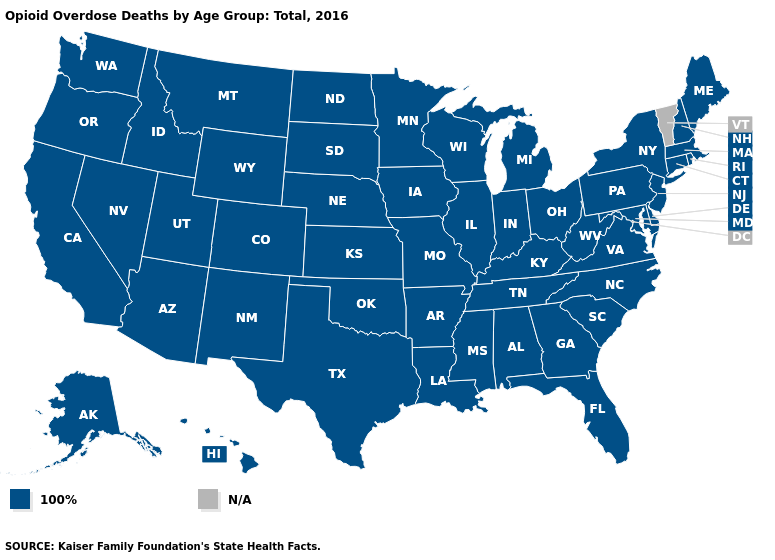Name the states that have a value in the range N/A?
Short answer required. Vermont. What is the value of Missouri?
Short answer required. 100%. Which states have the lowest value in the USA?
Concise answer only. Alabama, Alaska, Arizona, Arkansas, California, Colorado, Connecticut, Delaware, Florida, Georgia, Hawaii, Idaho, Illinois, Indiana, Iowa, Kansas, Kentucky, Louisiana, Maine, Maryland, Massachusetts, Michigan, Minnesota, Mississippi, Missouri, Montana, Nebraska, Nevada, New Hampshire, New Jersey, New Mexico, New York, North Carolina, North Dakota, Ohio, Oklahoma, Oregon, Pennsylvania, Rhode Island, South Carolina, South Dakota, Tennessee, Texas, Utah, Virginia, Washington, West Virginia, Wisconsin, Wyoming. Among the states that border Texas , which have the highest value?
Concise answer only. Arkansas, Louisiana, New Mexico, Oklahoma. What is the highest value in states that border Arizona?
Write a very short answer. 100%. What is the value of Connecticut?
Write a very short answer. 100%. Name the states that have a value in the range 100%?
Give a very brief answer. Alabama, Alaska, Arizona, Arkansas, California, Colorado, Connecticut, Delaware, Florida, Georgia, Hawaii, Idaho, Illinois, Indiana, Iowa, Kansas, Kentucky, Louisiana, Maine, Maryland, Massachusetts, Michigan, Minnesota, Mississippi, Missouri, Montana, Nebraska, Nevada, New Hampshire, New Jersey, New Mexico, New York, North Carolina, North Dakota, Ohio, Oklahoma, Oregon, Pennsylvania, Rhode Island, South Carolina, South Dakota, Tennessee, Texas, Utah, Virginia, Washington, West Virginia, Wisconsin, Wyoming. What is the value of Colorado?
Answer briefly. 100%. Name the states that have a value in the range 100%?
Quick response, please. Alabama, Alaska, Arizona, Arkansas, California, Colorado, Connecticut, Delaware, Florida, Georgia, Hawaii, Idaho, Illinois, Indiana, Iowa, Kansas, Kentucky, Louisiana, Maine, Maryland, Massachusetts, Michigan, Minnesota, Mississippi, Missouri, Montana, Nebraska, Nevada, New Hampshire, New Jersey, New Mexico, New York, North Carolina, North Dakota, Ohio, Oklahoma, Oregon, Pennsylvania, Rhode Island, South Carolina, South Dakota, Tennessee, Texas, Utah, Virginia, Washington, West Virginia, Wisconsin, Wyoming. What is the lowest value in states that border West Virginia?
Be succinct. 100%. Which states have the lowest value in the USA?
Quick response, please. Alabama, Alaska, Arizona, Arkansas, California, Colorado, Connecticut, Delaware, Florida, Georgia, Hawaii, Idaho, Illinois, Indiana, Iowa, Kansas, Kentucky, Louisiana, Maine, Maryland, Massachusetts, Michigan, Minnesota, Mississippi, Missouri, Montana, Nebraska, Nevada, New Hampshire, New Jersey, New Mexico, New York, North Carolina, North Dakota, Ohio, Oklahoma, Oregon, Pennsylvania, Rhode Island, South Carolina, South Dakota, Tennessee, Texas, Utah, Virginia, Washington, West Virginia, Wisconsin, Wyoming. Name the states that have a value in the range N/A?
Concise answer only. Vermont. 